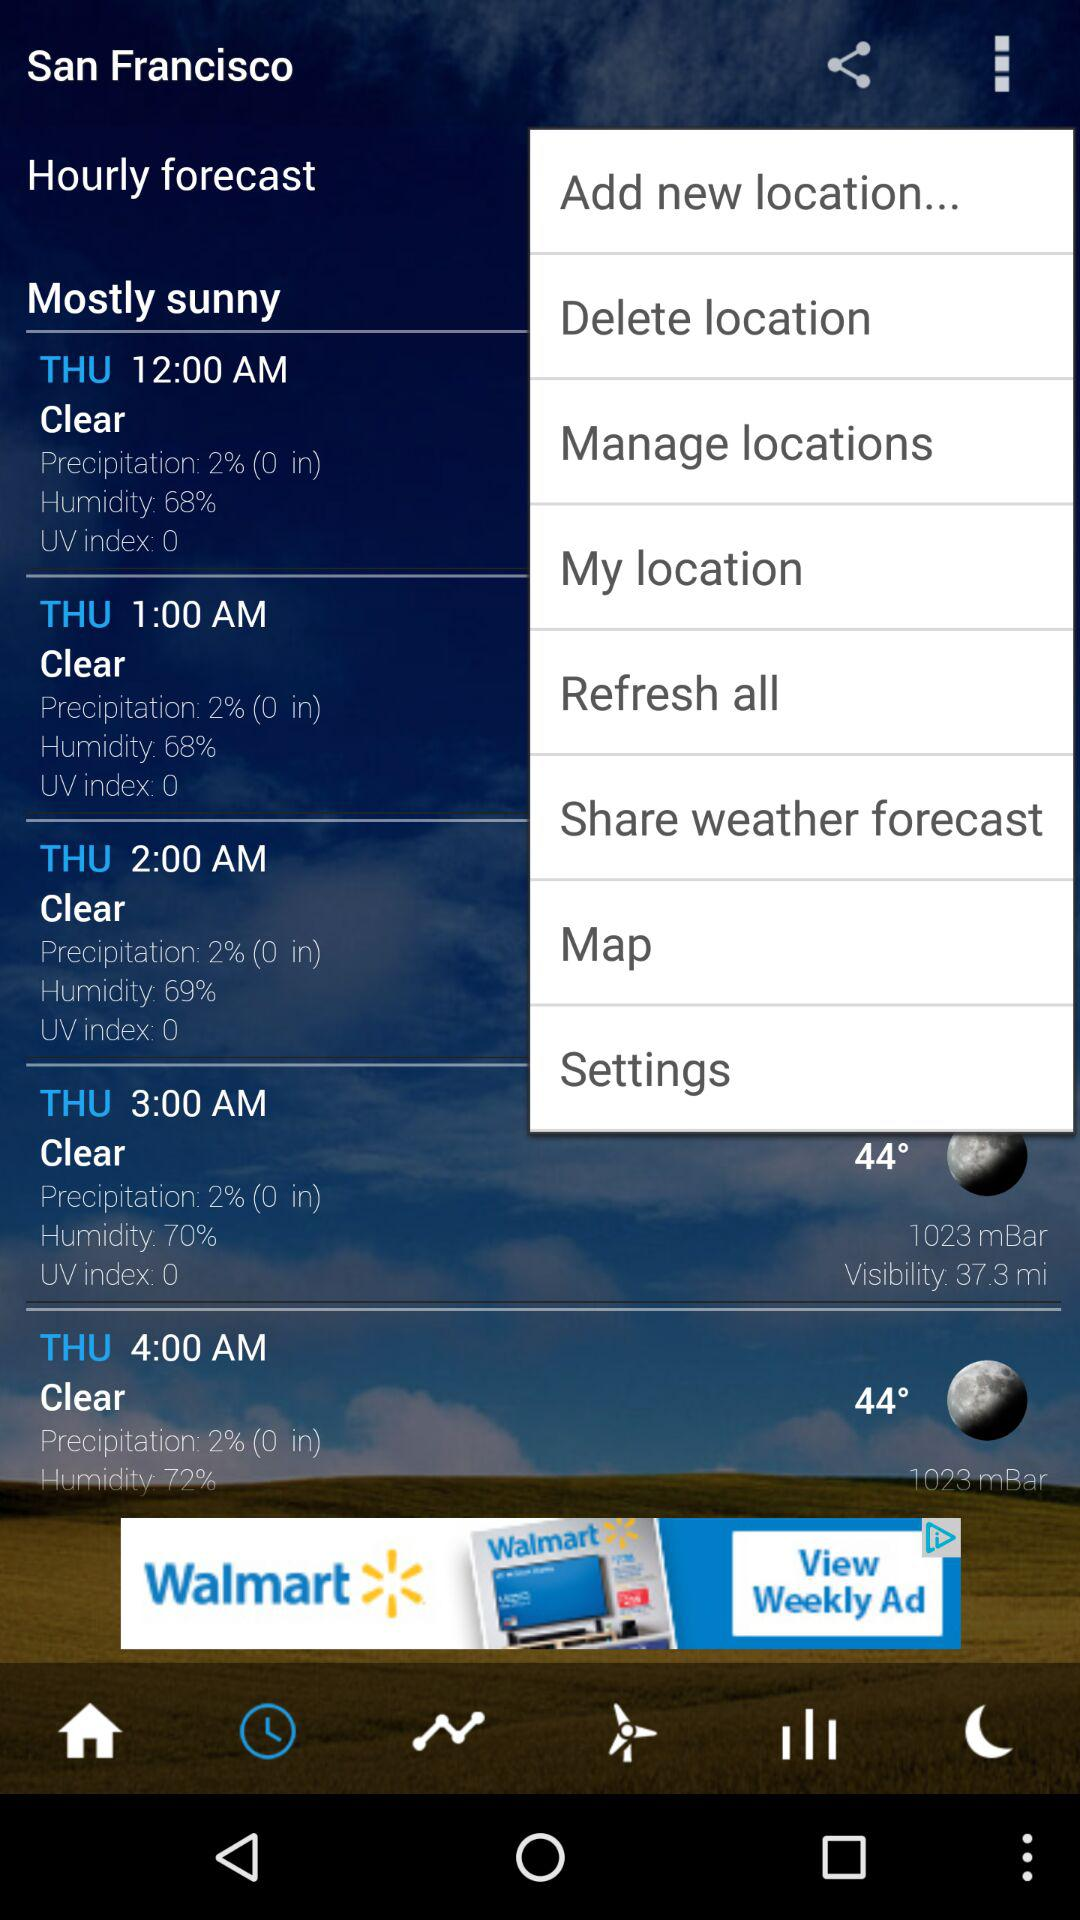What's the UV index number at 2 a.m.? The UV index number is 0. 